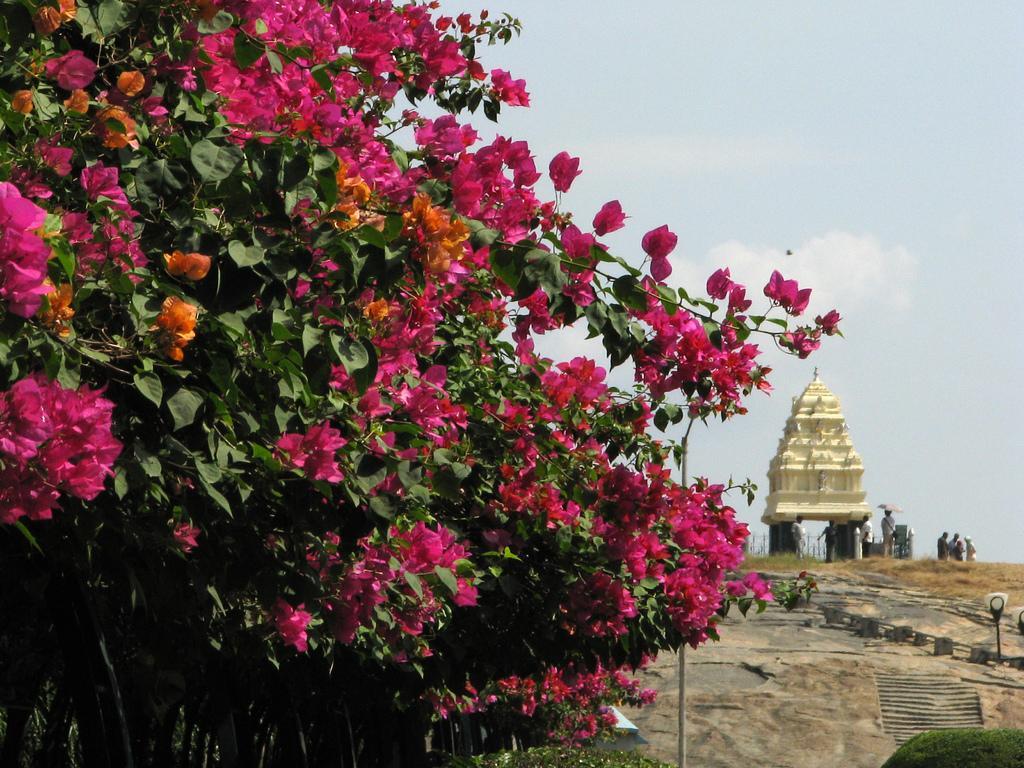In one or two sentences, can you explain what this image depicts? In this image, we can see trees with flowers. On the right side of the image, we can see temple, people, stairs, poles, plants and the sky. 